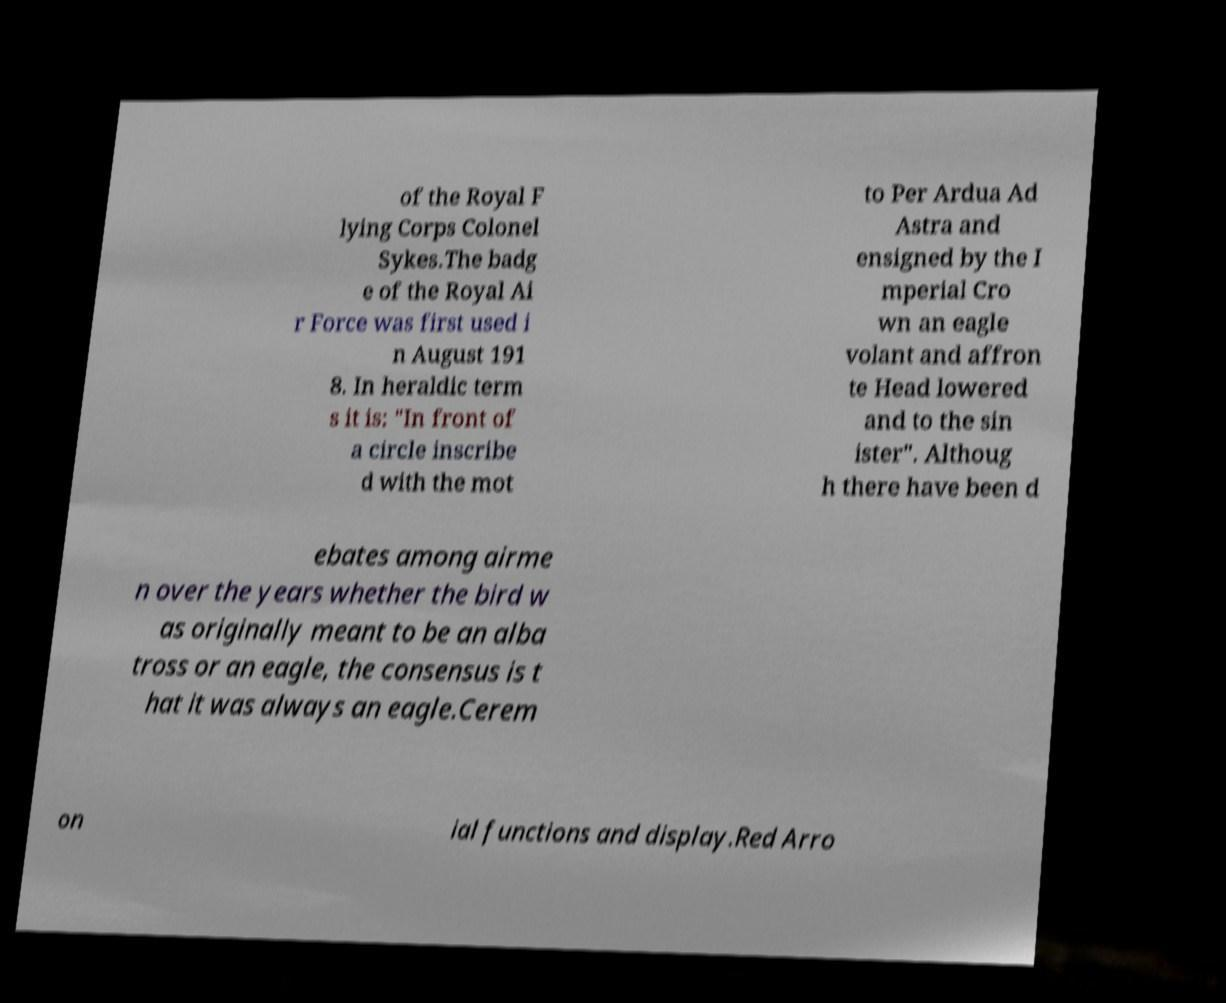Could you extract and type out the text from this image? of the Royal F lying Corps Colonel Sykes.The badg e of the Royal Ai r Force was first used i n August 191 8. In heraldic term s it is: "In front of a circle inscribe d with the mot to Per Ardua Ad Astra and ensigned by the I mperial Cro wn an eagle volant and affron te Head lowered and to the sin ister". Althoug h there have been d ebates among airme n over the years whether the bird w as originally meant to be an alba tross or an eagle, the consensus is t hat it was always an eagle.Cerem on ial functions and display.Red Arro 